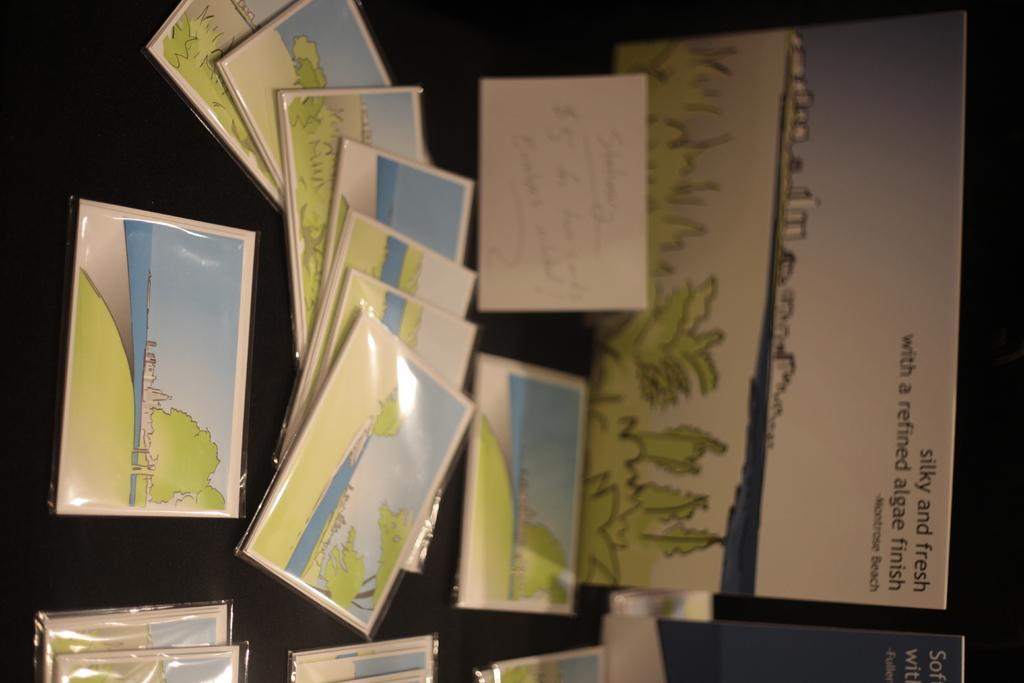<image>
Share a concise interpretation of the image provided. Some greeting cards nest to a nice drawing of a landscape which has a writing on top that starts with "silky and fresh". 